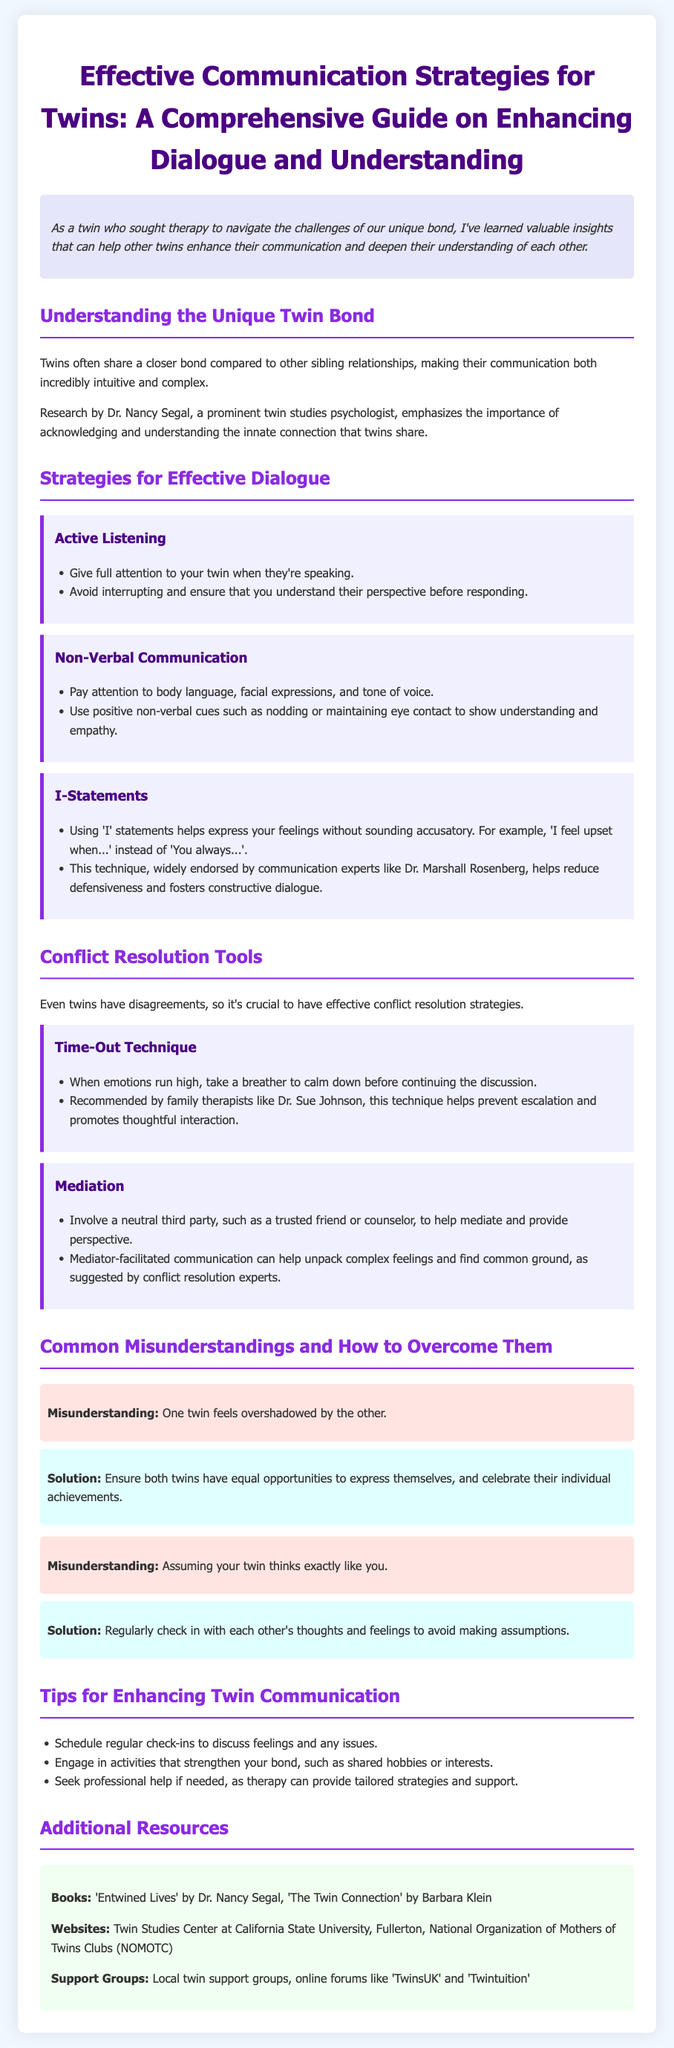What is the title of the guide? The title of the guide is stated at the top of the document.
Answer: Effective Communication Strategies for Twins: A Comprehensive Guide on Enhancing Dialogue and Understanding Who conducted research on twin studies mentioned in the document? The document references a prominent twin studies psychologist.
Answer: Dr. Nancy Segal What communication technique helps reduce defensiveness? The document describes a specific communication technique to help express feelings without being accusatory.
Answer: I-Statements What technique is recommended when emotions run high? The document states a technique to calm down before continuing discussions.
Answer: Time-Out Technique How many strategies for effective dialogue are mentioned in the document? The document lists the number of strategies explicitly.
Answer: Three What is one of the common misunderstandings listed in the guide? The guide provides a specific example of a misunderstanding that twins may face.
Answer: One twin feels overshadowed by the other What should twins schedule regularly to discuss feelings? The guide suggests organizing a specific type of meeting to improve communication.
Answer: Regular check-ins Which book is recommended in the additional resources? The document mentions a specific book as a resource.
Answer: Entwined Lives What does the guide suggest involving in mediation? The document describes a type of individual to call upon for mediation assistance.
Answer: A neutral third party 